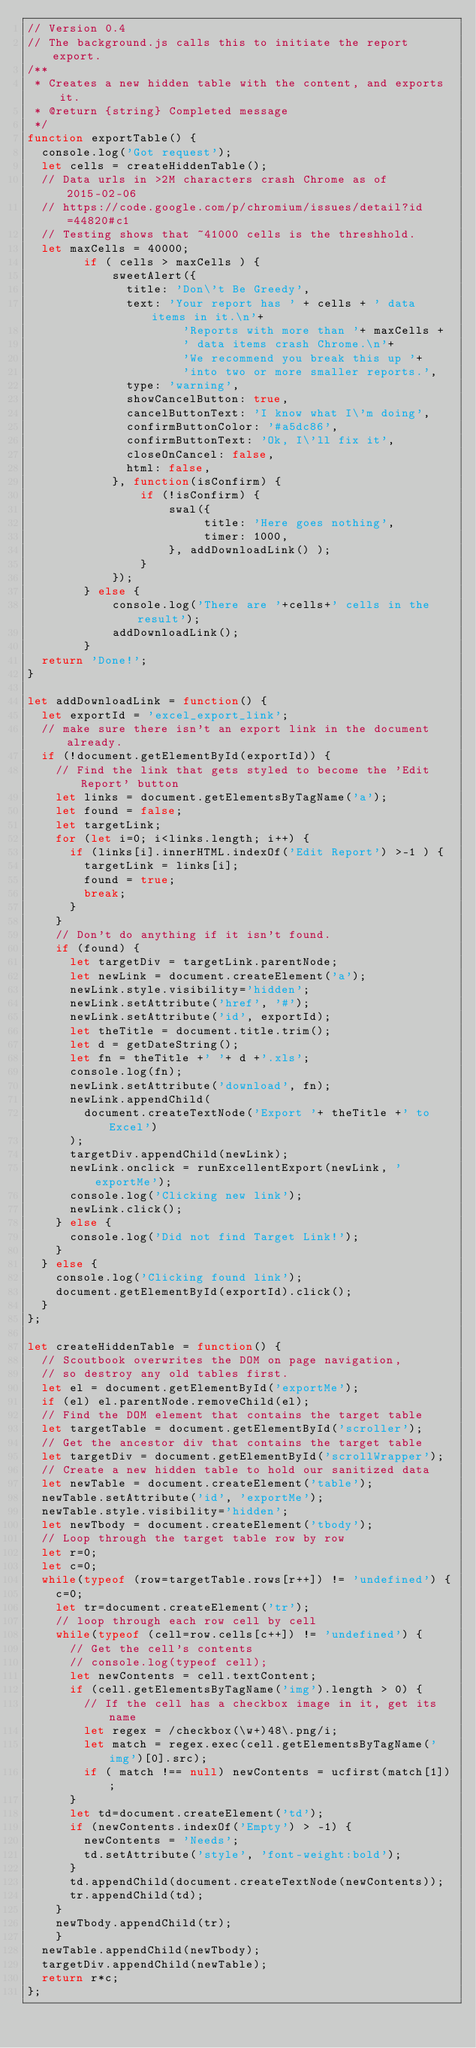Convert code to text. <code><loc_0><loc_0><loc_500><loc_500><_JavaScript_>// Version 0.4
// The background.js calls this to initiate the report export.
/**
 * Creates a new hidden table with the content, and exports it.
 * @return {string} Completed message
 */
function exportTable() {
  console.log('Got request');
	let cells = createHiddenTable();
  // Data urls in >2M characters crash Chrome as of 2015-02-06
  // https://code.google.com/p/chromium/issues/detail?id=44820#c1
  // Testing shows that ~41000 cells is the threshhold.
  let maxCells = 40000;
        if ( cells > maxCells ) {
            sweetAlert({
              title: 'Don\'t Be Greedy',
              text: 'Your report has ' + cells + ' data items in it.\n'+
                      'Reports with more than '+ maxCells +
                      ' data items crash Chrome.\n'+
                      'We recommend you break this up '+
                      'into two or more smaller reports.',
              type: 'warning',
              showCancelButton: true,
              cancelButtonText: 'I know what I\'m doing',
              confirmButtonColor: '#a5dc86',
              confirmButtonText: 'Ok, I\'ll fix it',
              closeOnCancel: false,
              html: false,
            }, function(isConfirm) {
                if (!isConfirm) {
                    swal({
                         title: 'Here goes nothing',
                         timer: 1000,
                    }, addDownloadLink() );
                }
            });
        } else {
            console.log('There are '+cells+' cells in the result');
            addDownloadLink();
        }
	return 'Done!';
}

let addDownloadLink = function() {
  let exportId = 'excel_export_link';
	// make sure there isn't an export link in the document already.
	if (!document.getElementById(exportId)) {
		// Find the link that gets styled to become the 'Edit Report' button
		let links = document.getElementsByTagName('a');
		let found = false;
    let targetLink;
		for (let i=0; i<links.length; i++) {
			if (links[i].innerHTML.indexOf('Edit Report') >-1 ) {
				targetLink = links[i];
				found = true;
				break;
			}
		}
		// Don't do anything if it isn't found.
		if (found) {
      let targetDiv = targetLink.parentNode;
			let newLink = document.createElement('a');
			newLink.style.visibility='hidden';
			newLink.setAttribute('href', '#');
			newLink.setAttribute('id', exportId);
			let theTitle = document.title.trim();
			let d = getDateString();
			let fn = theTitle +' '+ d +'.xls';
			console.log(fn);
			newLink.setAttribute('download', fn);
			newLink.appendChild(
        document.createTextNode('Export '+ theTitle +' to Excel')
      );
			targetDiv.appendChild(newLink);
			newLink.onclick = runExcellentExport(newLink, 'exportMe');
			console.log('Clicking new link');
			newLink.click();
		} else {
      console.log('Did not find Target Link!');
    }
	} else {
    console.log('Clicking found link');
    document.getElementById(exportId).click();
	}
};

let createHiddenTable = function() {
  // Scoutbook overwrites the DOM on page navigation,
  // so destroy any old tables first.
  let el = document.getElementById('exportMe');
	if (el) el.parentNode.removeChild(el);
	// Find the DOM element that contains the target table
	let targetTable = document.getElementById('scroller');
	// Get the ancestor div that contains the target table
	let targetDiv = document.getElementById('scrollWrapper');
	// Create a new hidden table to hold our sanitized data
	let newTable = document.createElement('table');
	newTable.setAttribute('id', 'exportMe');
	newTable.style.visibility='hidden';
	let newTbody = document.createElement('tbody');
	// Loop through the target table row by row
	let r=0;
  let c=0;
	while(typeof (row=targetTable.rows[r++]) != 'undefined') {
		c=0;
		let tr=document.createElement('tr');
		// loop through each row cell by cell
		while(typeof (cell=row.cells[c++]) != 'undefined') {
			// Get the cell's contents
      // console.log(typeof cell);
      let newContents = cell.textContent;
      if (cell.getElementsByTagName('img').length > 0) {
        // If the cell has a checkbox image in it, get its name
        let regex = /checkbox(\w+)48\.png/i;
        let match = regex.exec(cell.getElementsByTagName('img')[0].src);
        if ( match !== null) newContents = ucfirst(match[1]);
      }
      let td=document.createElement('td');
      if (newContents.indexOf('Empty') > -1) {
        newContents = 'Needs';
        td.setAttribute('style', 'font-weight:bold');
      }
      td.appendChild(document.createTextNode(newContents));
      tr.appendChild(td);
		}
		newTbody.appendChild(tr);
		}
	newTable.appendChild(newTbody);
	targetDiv.appendChild(newTable);
  return r*c;
};
</code> 